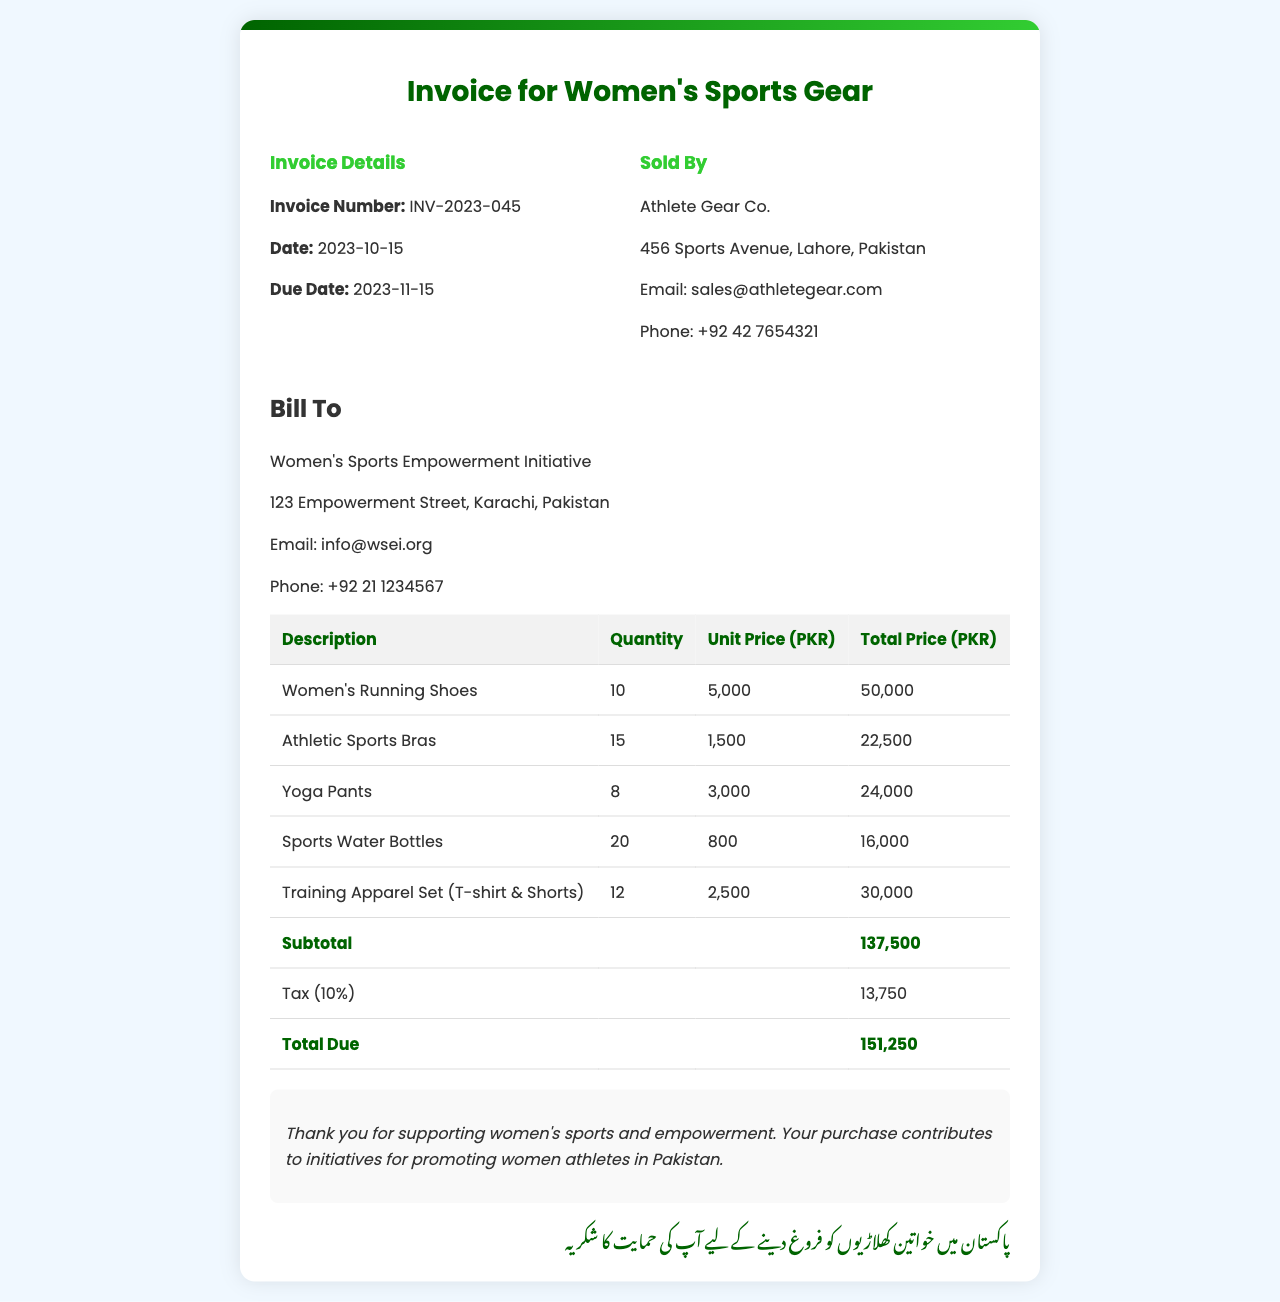What is the invoice number? The invoice number is specifically stated in the document as "INV-2023-045".
Answer: INV-2023-045 What is the date of the invoice? The date is mentioned clearly in the invoice details section.
Answer: 2023-10-15 Who is the seller? The document specifies the seller's name and details in the invoice.
Answer: Athlete Gear Co What are the total due amounts? The total due is clearly listed in the invoice table section.
Answer: 151,250 How many Women's Running Shoes were purchased? The quantity for Women's Running Shoes is provided in the itemized list.
Answer: 10 What is the subtotal amount before tax? The subtotal is summarized at the end of the invoice before tax is applied.
Answer: 137,500 What is the tax percentage applied? The document mentions the tax applied on the subtotal amount.
Answer: 10% What is the billing address? The billing address is provided in the invoice and details the organization being billed.
Answer: 123 Empowerment Street, Karachi, Pakistan What is the total quantity of Sports Water Bottles purchased? The itemized list includes the number of Sports Water Bottles purchased.
Answer: 20 